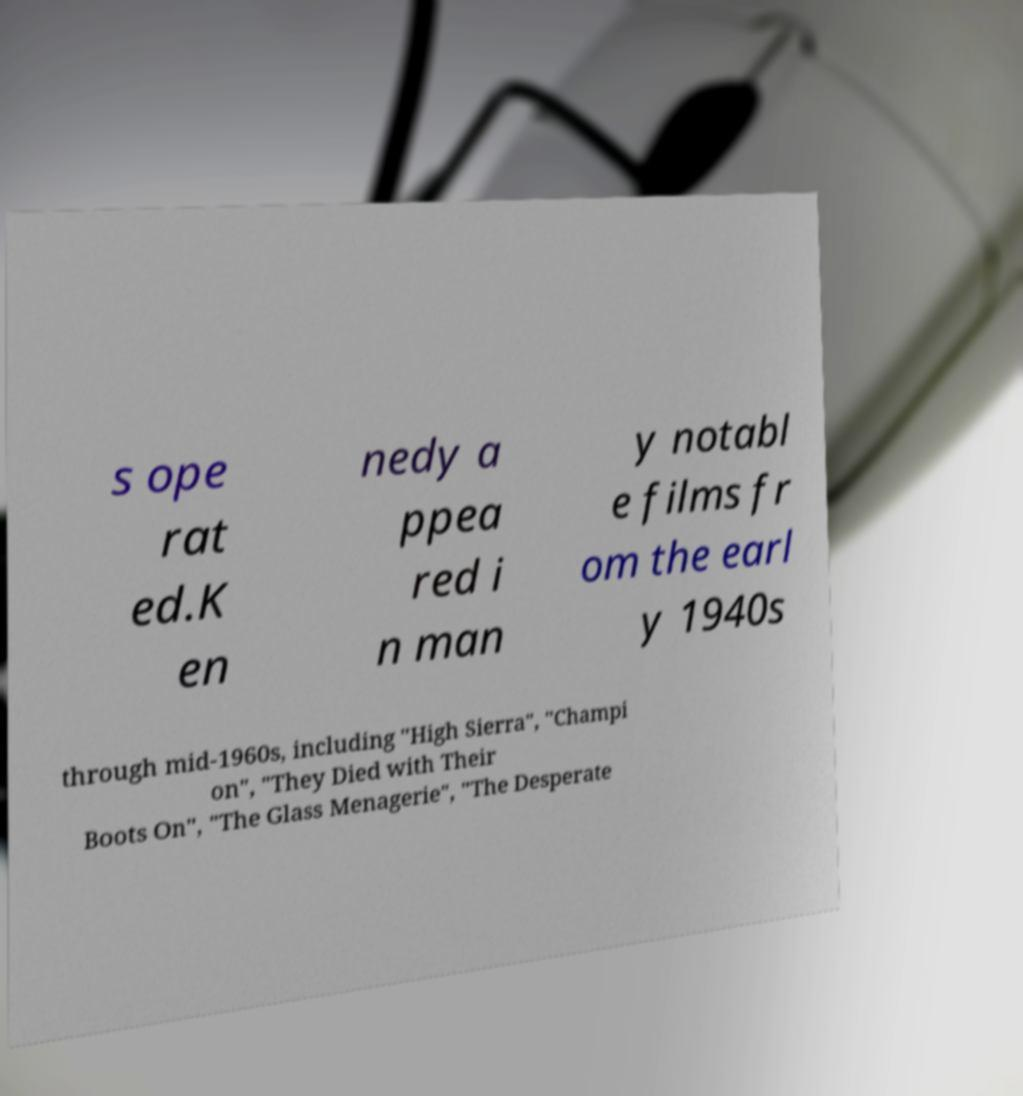What messages or text are displayed in this image? I need them in a readable, typed format. s ope rat ed.K en nedy a ppea red i n man y notabl e films fr om the earl y 1940s through mid-1960s, including "High Sierra", "Champi on", "They Died with Their Boots On", "The Glass Menagerie", "The Desperate 